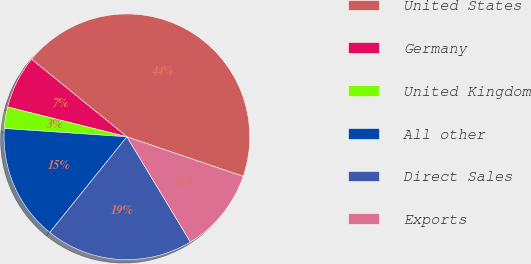Convert chart. <chart><loc_0><loc_0><loc_500><loc_500><pie_chart><fcel>United States<fcel>Germany<fcel>United Kingdom<fcel>All other<fcel>Direct Sales<fcel>Exports<nl><fcel>44.36%<fcel>6.97%<fcel>2.82%<fcel>15.28%<fcel>19.44%<fcel>11.13%<nl></chart> 